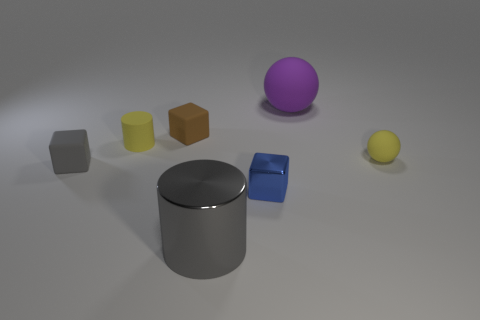Subtract all gray cubes. How many cubes are left? 2 Subtract all blue blocks. How many blocks are left? 2 Add 1 small yellow spheres. How many objects exist? 8 Subtract 1 spheres. How many spheres are left? 1 Add 3 large metallic objects. How many large metallic objects are left? 4 Add 4 brown rubber objects. How many brown rubber objects exist? 5 Subtract 0 red cubes. How many objects are left? 7 Subtract all cubes. How many objects are left? 4 Subtract all red cubes. Subtract all cyan spheres. How many cubes are left? 3 Subtract all purple balls. How many gray cylinders are left? 1 